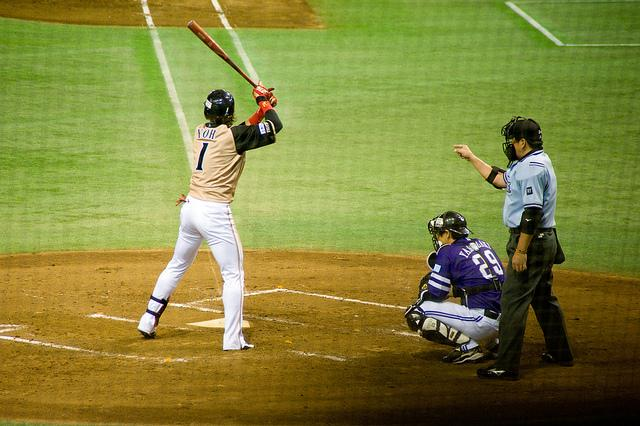Why is the guy in purple crouching? catch ball 